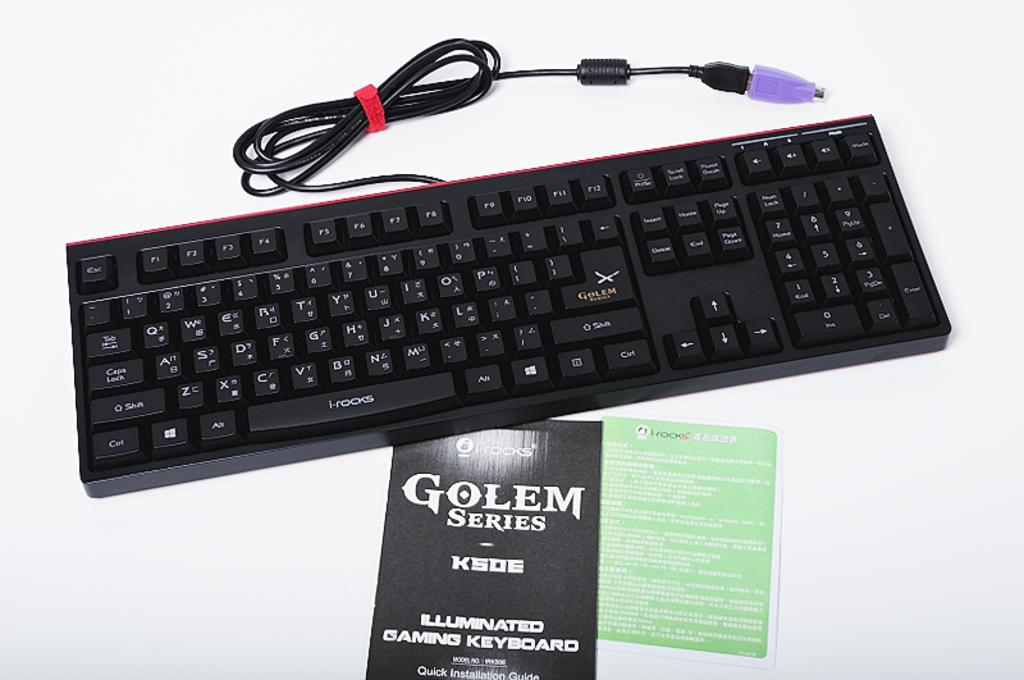<image>
Offer a succinct explanation of the picture presented. a golem series keyboard is displayed with its cord 